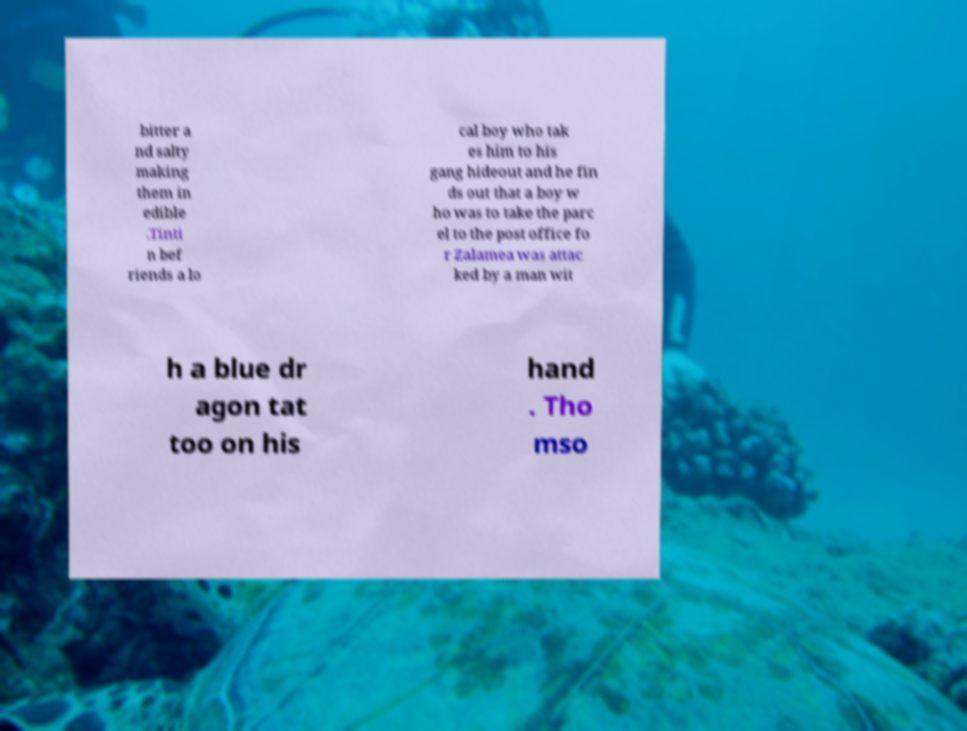Please identify and transcribe the text found in this image. bitter a nd salty making them in edible .Tinti n bef riends a lo cal boy who tak es him to his gang hideout and he fin ds out that a boy w ho was to take the parc el to the post office fo r Zalamea was attac ked by a man wit h a blue dr agon tat too on his hand . Tho mso 